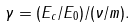<formula> <loc_0><loc_0><loc_500><loc_500>\gamma = ( E _ { c } / E _ { 0 } ) / ( \nu / m ) .</formula> 